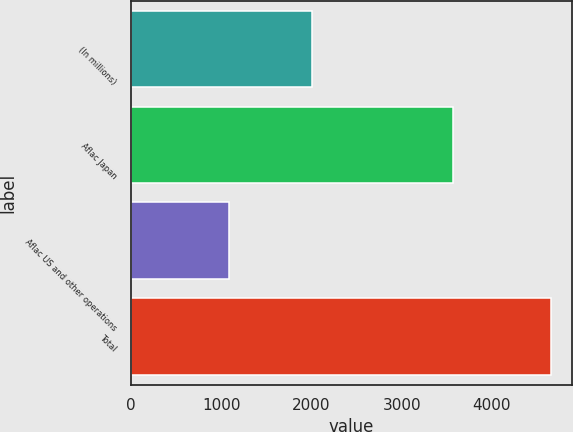Convert chart. <chart><loc_0><loc_0><loc_500><loc_500><bar_chart><fcel>(In millions)<fcel>Aflac Japan<fcel>Aflac US and other operations<fcel>Total<nl><fcel>2007<fcel>3573<fcel>1083<fcel>4656<nl></chart> 